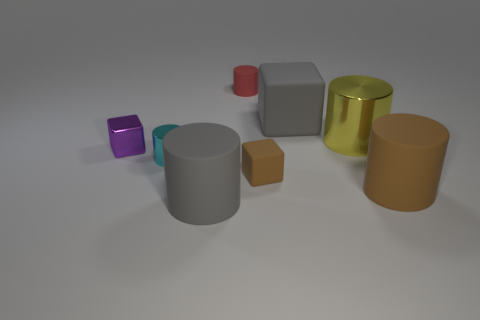Subtract all cyan cylinders. How many cylinders are left? 4 Subtract all yellow cylinders. How many cylinders are left? 4 Subtract 1 cylinders. How many cylinders are left? 4 Subtract all blue cylinders. Subtract all purple balls. How many cylinders are left? 5 Add 1 small metallic objects. How many objects exist? 9 Subtract all blocks. How many objects are left? 5 Subtract 0 red balls. How many objects are left? 8 Subtract all tiny cyan metal objects. Subtract all cyan objects. How many objects are left? 6 Add 4 small matte cylinders. How many small matte cylinders are left? 5 Add 2 blue matte balls. How many blue matte balls exist? 2 